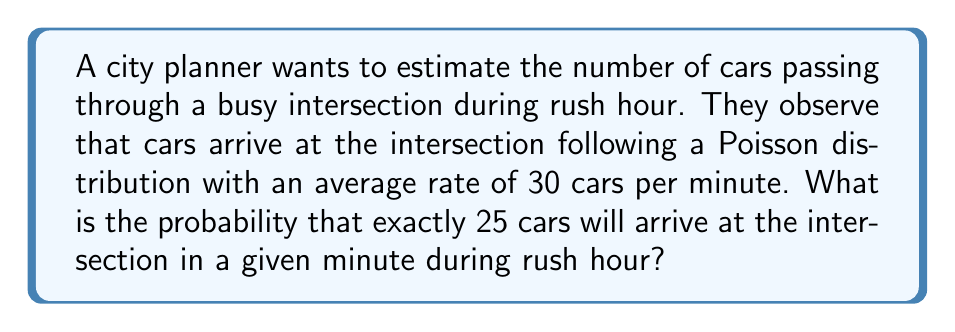Provide a solution to this math problem. To solve this problem, we need to use the Poisson probability mass function. The Poisson distribution is often used to model the number of events occurring in a fixed interval of time or space.

Step 1: Identify the parameters
- $\lambda$ (lambda) = average rate of cars arriving per minute = 30
- $k$ = number of cars we want to calculate the probability for = 25

Step 2: Recall the Poisson probability mass function
$$P(X = k) = \frac{e^{-\lambda} \lambda^k}{k!}$$

Where:
- $e$ is Euler's number (approximately 2.71828)
- $\lambda$ is the average rate of occurrence
- $k$ is the number of occurrences we're interested in
- $k!$ is the factorial of $k$

Step 3: Plug in the values
$$P(X = 25) = \frac{e^{-30} 30^{25}}{25!}$$

Step 4: Calculate the result
Using a calculator or computer (as this involves very large numbers):

$$P(X = 25) \approx 0.0428$$

This can be interpreted as a 4.28% chance of exactly 25 cars arriving in a given minute during rush hour.
Answer: 0.0428 or 4.28% 